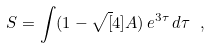<formula> <loc_0><loc_0><loc_500><loc_500>S = \int ( 1 - \sqrt { [ } 4 ] { A } ) \, e ^ { 3 \tau } \, d \tau \ ,</formula> 